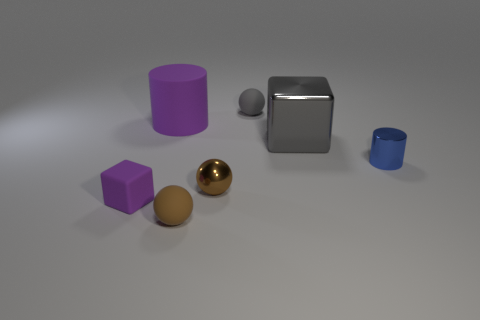Is the material of the thing that is behind the large matte thing the same as the purple object behind the small blue shiny thing?
Provide a short and direct response. Yes. The block that is in front of the cylinder that is in front of the large gray metallic block is made of what material?
Provide a succinct answer. Rubber. What material is the cube that is in front of the big gray shiny object?
Offer a very short reply. Rubber. How many large metal things have the same shape as the big rubber object?
Make the answer very short. 0. Does the shiny cylinder have the same color as the small rubber block?
Offer a very short reply. No. What material is the cylinder to the right of the small brown ball behind the matte sphere in front of the small metallic cylinder?
Your response must be concise. Metal. There is a large purple rubber cylinder; are there any big gray things to the left of it?
Ensure brevity in your answer.  No. There is a object that is the same size as the gray metallic block; what shape is it?
Offer a terse response. Cylinder. Is the gray sphere made of the same material as the big cylinder?
Your answer should be very brief. Yes. What number of metal objects are either small cylinders or big cubes?
Keep it short and to the point. 2. 